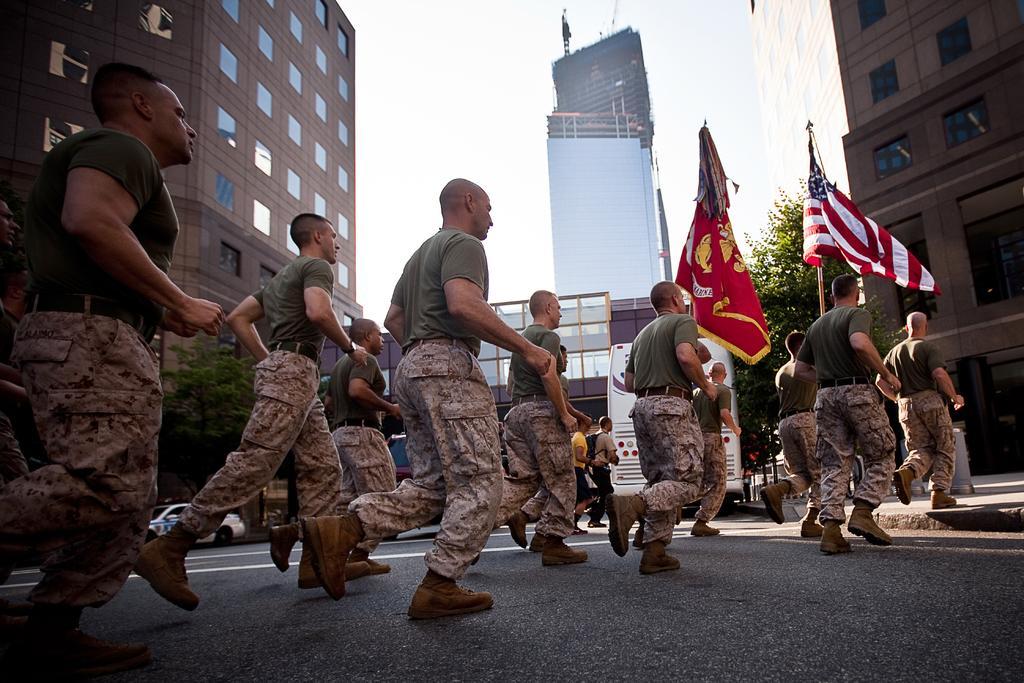Please provide a concise description of this image. In this image we can see the persons with uniforms running on the road. We can also see the flags, buildings and also the vehicles and trees. Sky is also visible. 